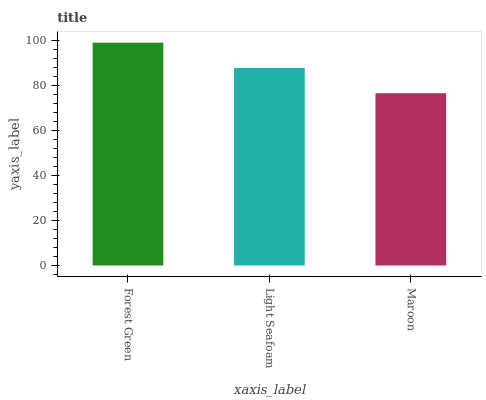Is Maroon the minimum?
Answer yes or no. Yes. Is Forest Green the maximum?
Answer yes or no. Yes. Is Light Seafoam the minimum?
Answer yes or no. No. Is Light Seafoam the maximum?
Answer yes or no. No. Is Forest Green greater than Light Seafoam?
Answer yes or no. Yes. Is Light Seafoam less than Forest Green?
Answer yes or no. Yes. Is Light Seafoam greater than Forest Green?
Answer yes or no. No. Is Forest Green less than Light Seafoam?
Answer yes or no. No. Is Light Seafoam the high median?
Answer yes or no. Yes. Is Light Seafoam the low median?
Answer yes or no. Yes. Is Forest Green the high median?
Answer yes or no. No. Is Forest Green the low median?
Answer yes or no. No. 